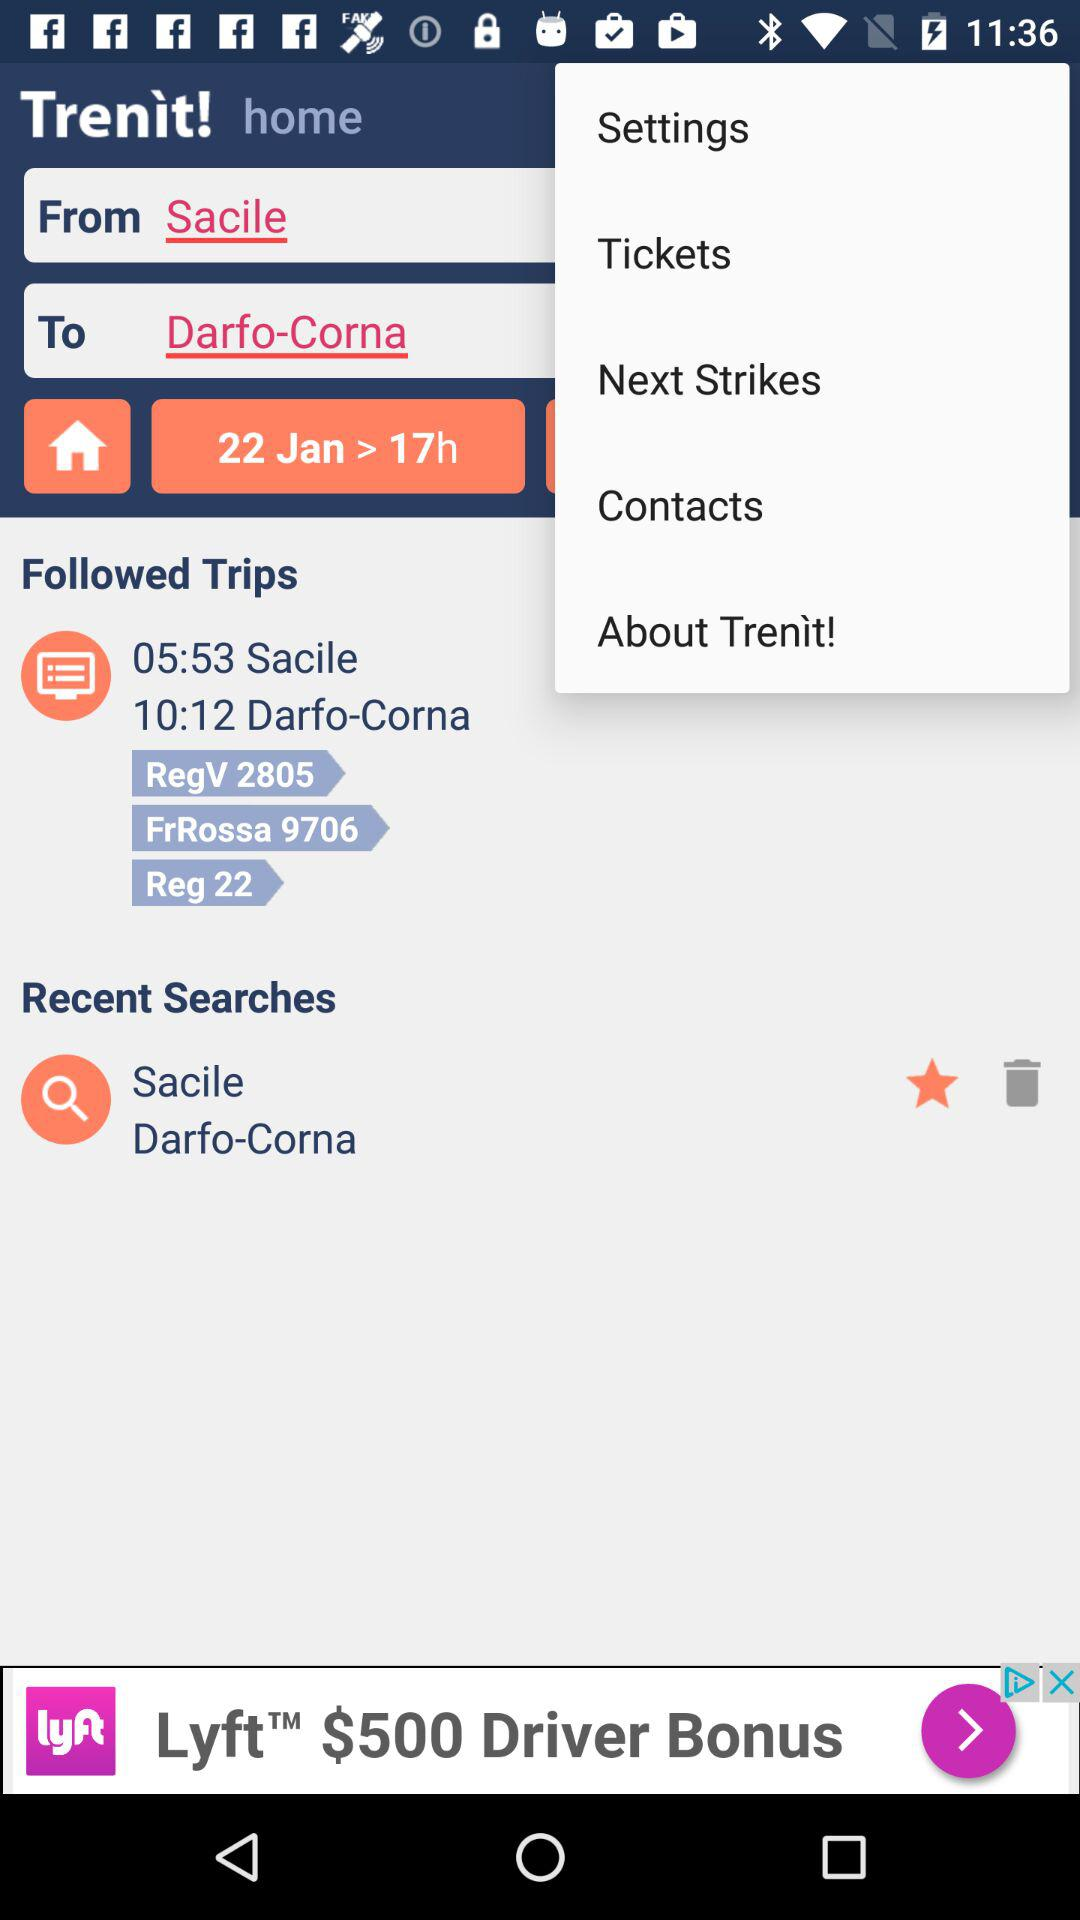When will I arrive in Dafo-Corna? You will arrive at 10:12. 